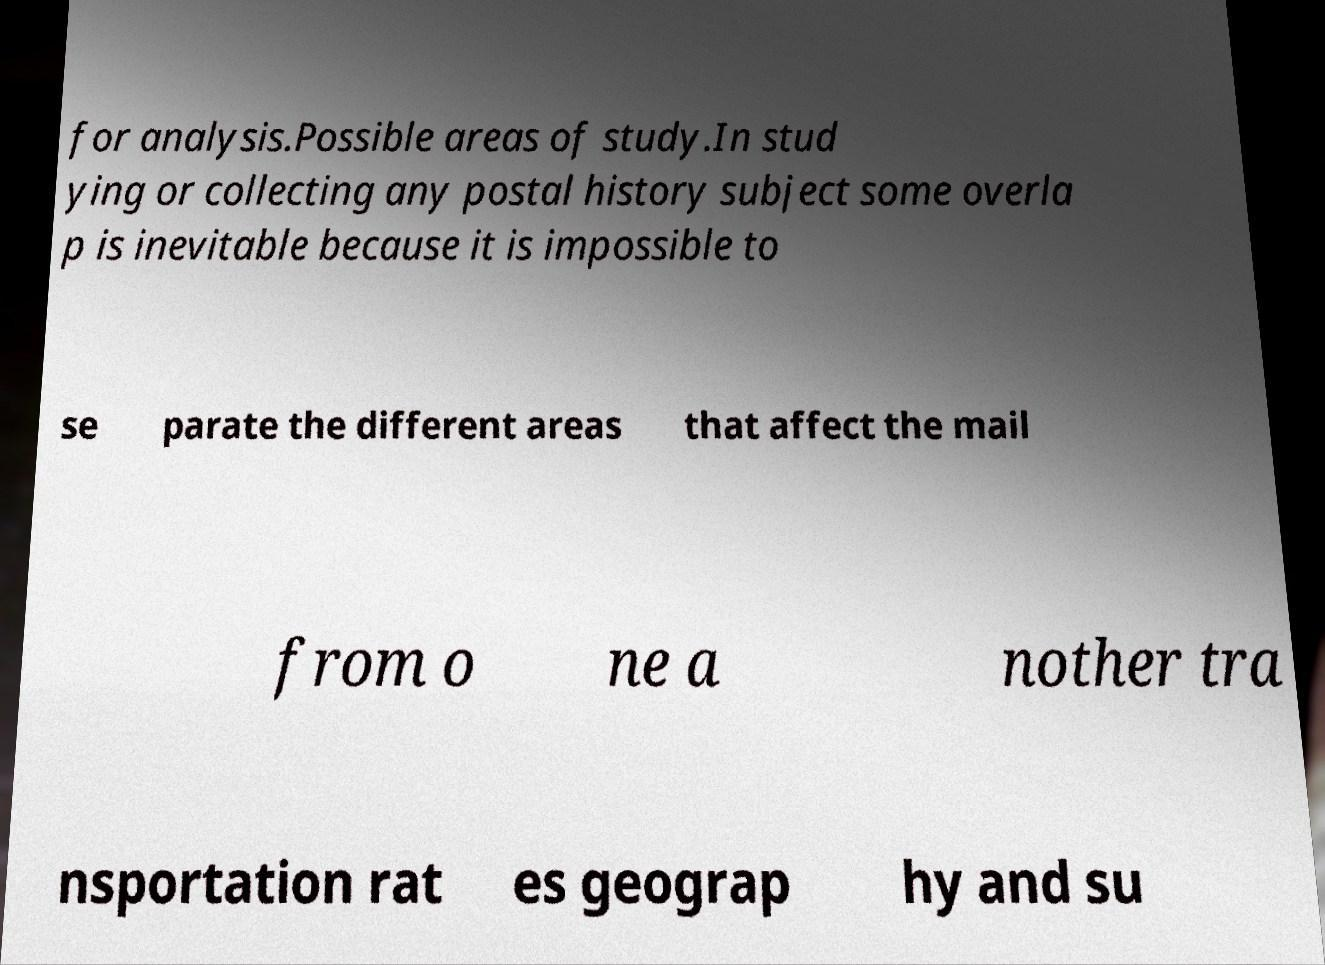What messages or text are displayed in this image? I need them in a readable, typed format. for analysis.Possible areas of study.In stud ying or collecting any postal history subject some overla p is inevitable because it is impossible to se parate the different areas that affect the mail from o ne a nother tra nsportation rat es geograp hy and su 